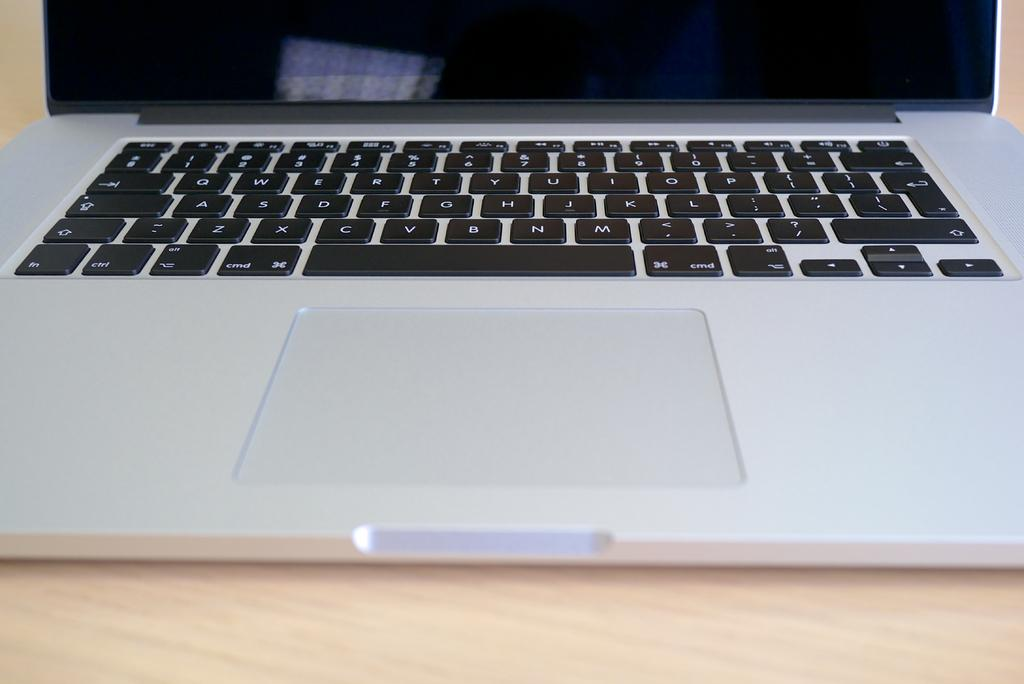<image>
Summarize the visual content of the image. A keyboard on a laptop has keys labeled cmd, alt and fn. 